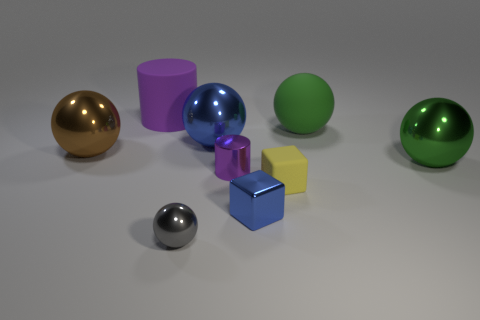What shape is the large matte thing that is the same color as the small cylinder?
Your response must be concise. Cylinder. Is there any other thing that has the same material as the yellow cube?
Your answer should be compact. Yes. Do the blue thing that is in front of the brown metallic ball and the purple object in front of the large brown metallic ball have the same shape?
Keep it short and to the point. No. How many metallic blocks are there?
Offer a terse response. 1. There is a small object that is made of the same material as the large cylinder; what shape is it?
Provide a short and direct response. Cube. Is there any other thing of the same color as the matte sphere?
Your answer should be very brief. Yes. There is a rubber ball; is it the same color as the matte thing in front of the green metallic ball?
Your answer should be very brief. No. Is the number of things that are in front of the brown metallic ball less than the number of small gray shiny balls?
Your response must be concise. No. There is a thing to the left of the large purple cylinder; what is its material?
Make the answer very short. Metal. What number of other objects are the same size as the rubber cylinder?
Offer a terse response. 4. 